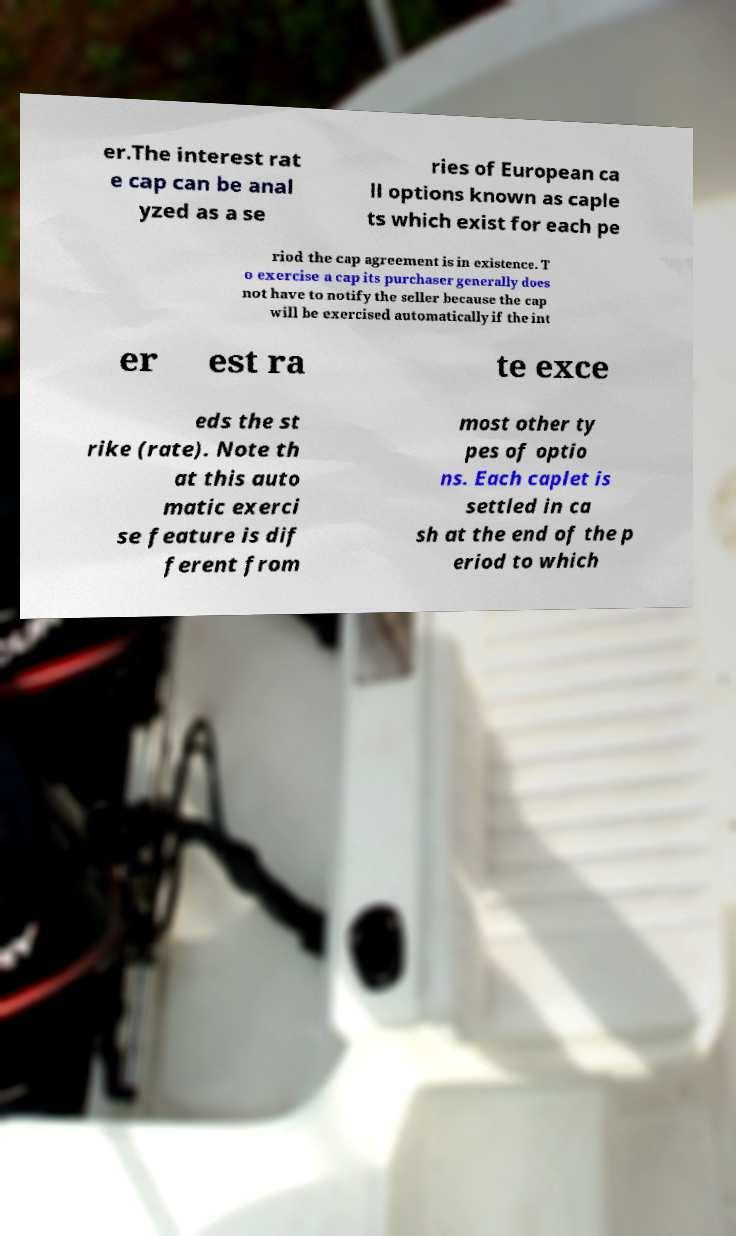Could you extract and type out the text from this image? er.The interest rat e cap can be anal yzed as a se ries of European ca ll options known as caple ts which exist for each pe riod the cap agreement is in existence. T o exercise a cap its purchaser generally does not have to notify the seller because the cap will be exercised automatically if the int er est ra te exce eds the st rike (rate). Note th at this auto matic exerci se feature is dif ferent from most other ty pes of optio ns. Each caplet is settled in ca sh at the end of the p eriod to which 